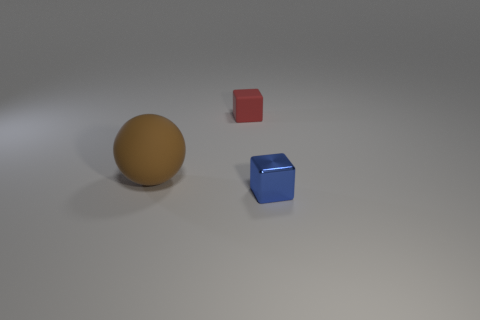There is a small thing in front of the red rubber thing; is it the same shape as the rubber thing to the right of the large brown thing? yes 